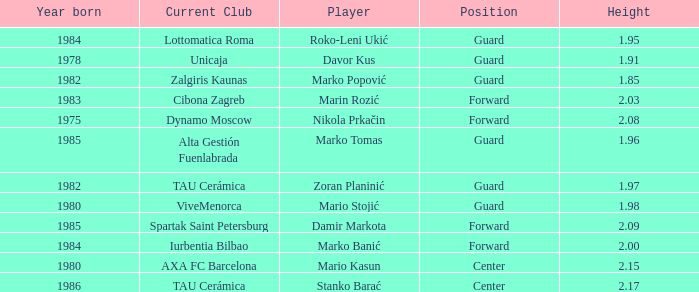What position does Mario Kasun play? Center. 